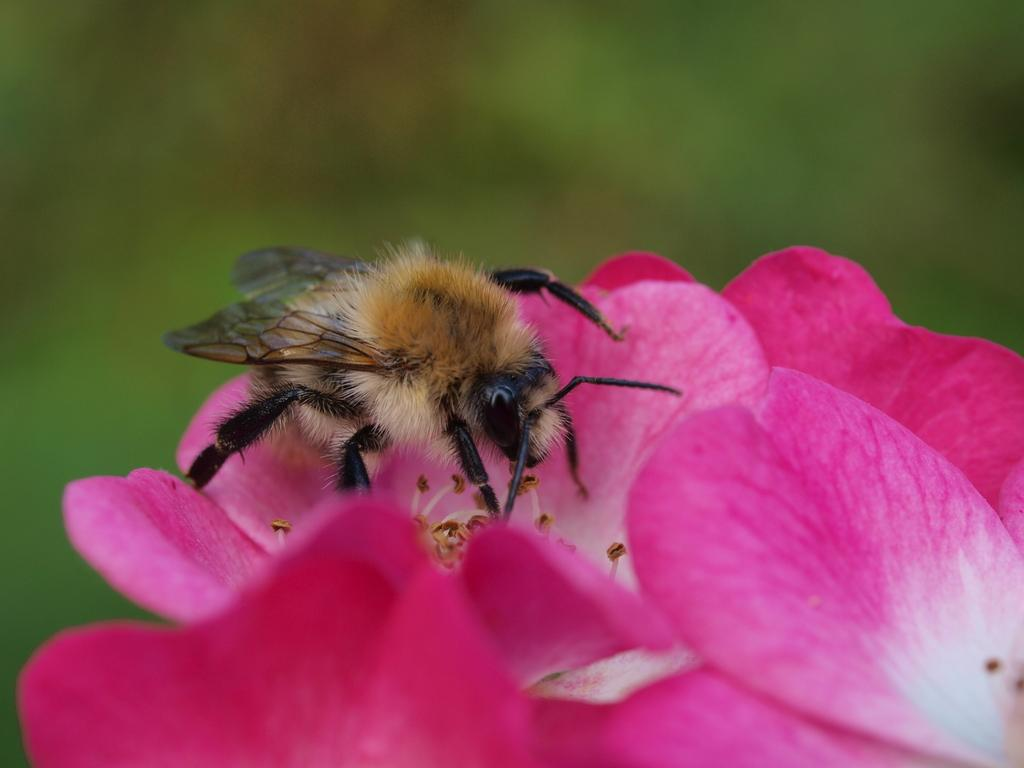What is present on the flower in the image? There is an insect on the flower in the image. Can you describe the insect's location on the flower? The insect is on the flower in the image. What type of instrument can be seen being played by the bear in the image? There is no bear or instrument present in the image; it only features an insect on a flower. 